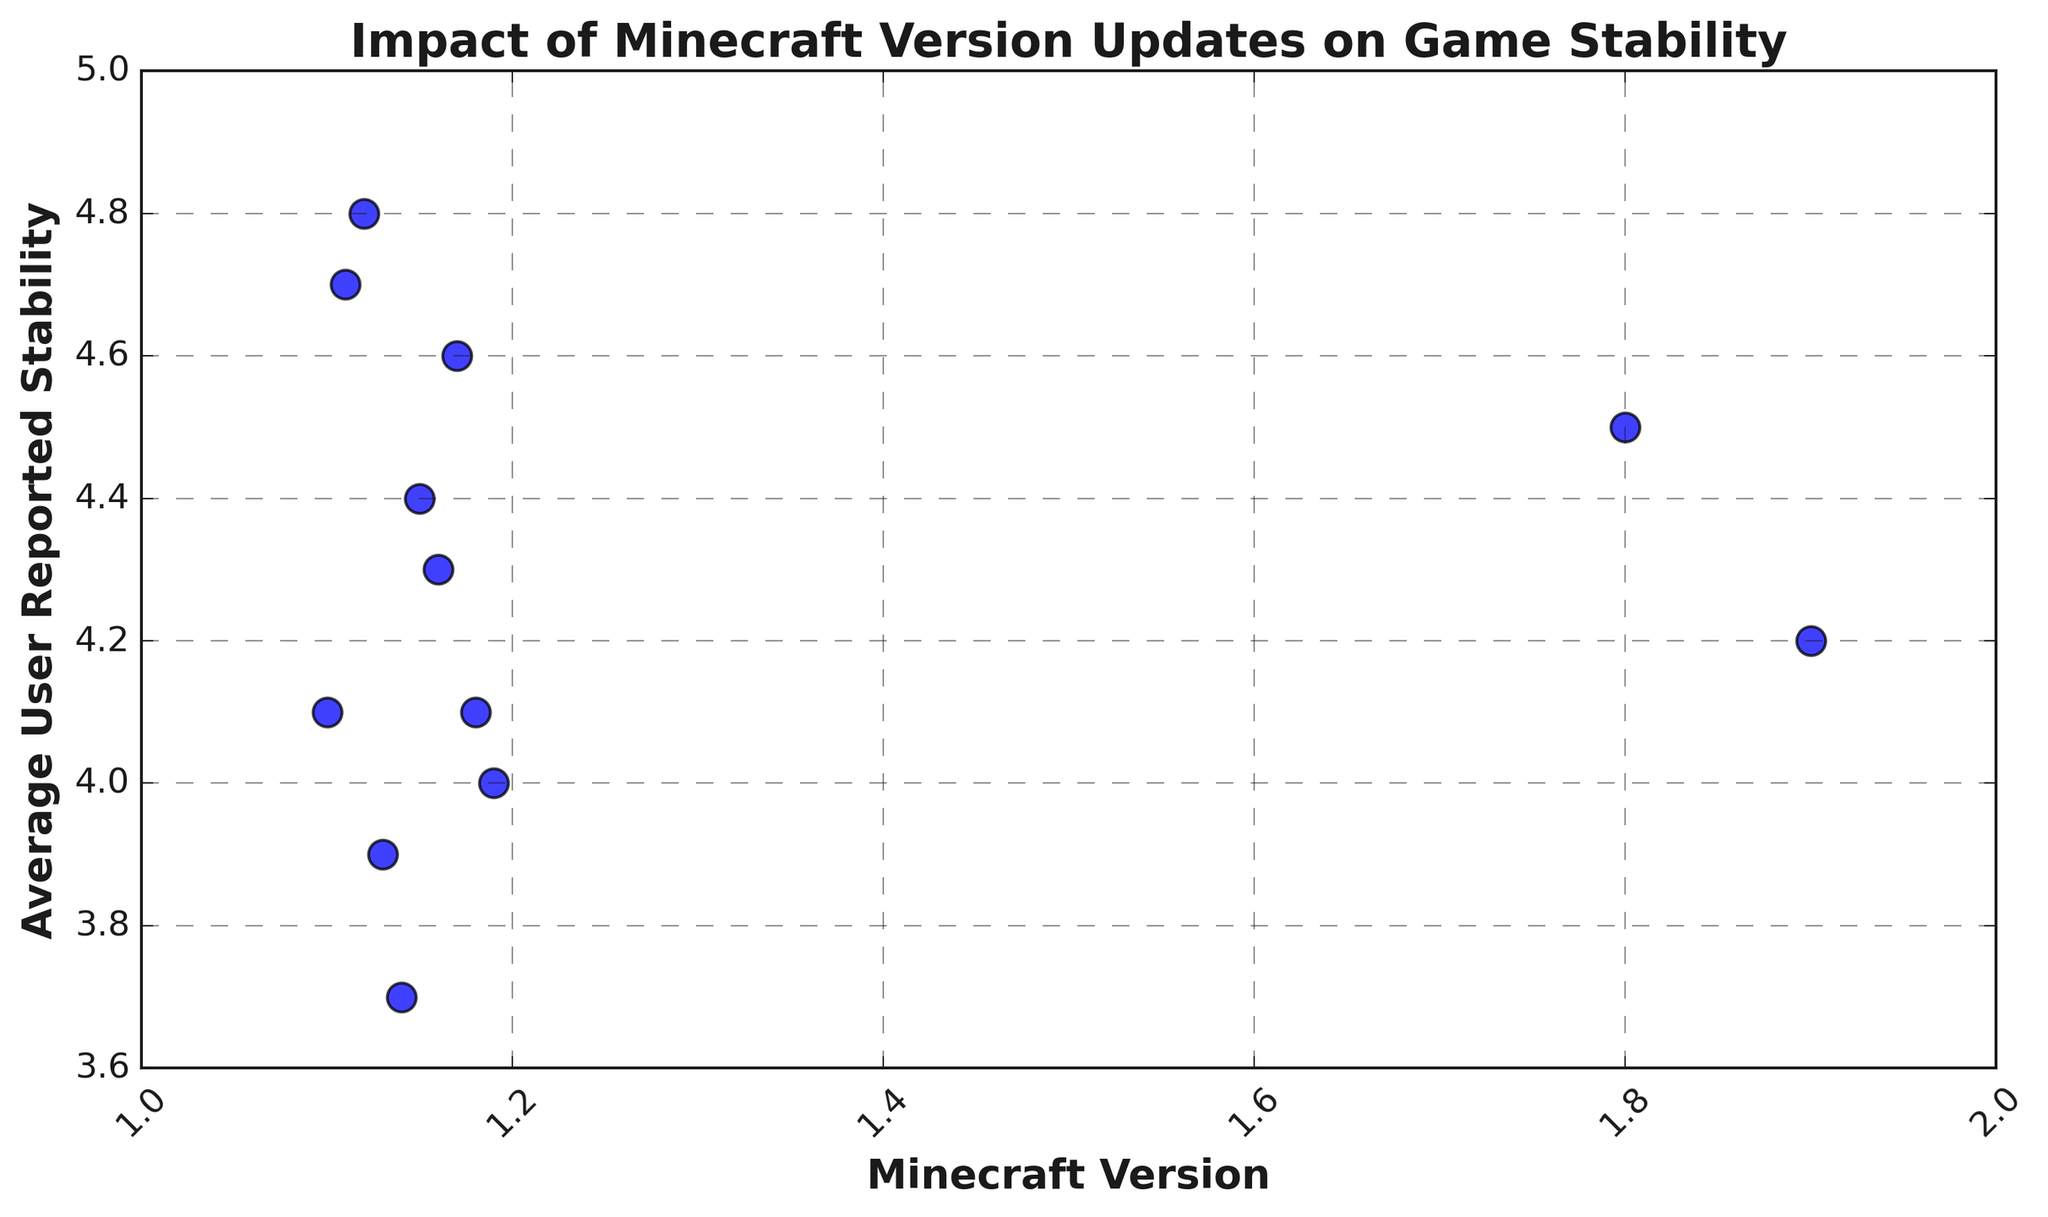Which Minecraft version has the highest average user-reported stability? The plot shows the average user-reported stability for different Minecraft versions. The highest point on the y-axis corresponds to version 1.12, with an average user-reported stability of 4.8.
Answer: 1.12 Which two versions have the lowest game stability ratings? The lowest game stability ratings on the y-axis correspond to versions 1.13 and 1.14, with average user-reported stabilities of 3.9 and 3.7, respectively.
Answer: 1.13 and 1.14 How does the stability of version 1.11 compare to version 1.16? Version 1.11 has a stability rating of 4.7, while version 1.16 has a stability rating of 4.3. Since 4.7 is greater than 4.3, version 1.11 has higher stability.
Answer: 1.11 is higher Which version shows a dip in stability right after a relatively high stability rating? Identify the version where a high stability rating is followed by a drop. Version 1.12 has a high stability of 4.8, and it dips to 3.9 in version 1.13.
Answer: 1.13 What is the average stability rating across all versions? Sum all stability ratings (4.5 + 4.2 + 4.1 + 4.7 + 4.8 + 3.9 + 3.7 + 4.4 + 4.3 + 4.6 + 4.1 + 4.0) and divide by the number of versions (12). The sum is 51.3, and the average is 51.3 / 12 = 4.275.
Answer: 4.275 Which version has a higher stability rating, 1.8 or 1.15? Compare the stability ratings for versions 1.8 (4.5) and 1.15 (4.4). Since 4.5 is greater than 4.4, version 1.8 has a higher stability rating.
Answer: 1.8 is higher What is the median stability rating among the displayed versions? Arrange the stability ratings in ascending order: 3.7, 3.9, 4.0, 4.1, 4.1, 4.2, 4.3, 4.4, 4.5, 4.6, 4.7, 4.8. The middle values are the 6th and 7th values (4.2 and 4.3). The median is the average of these values: (4.2 + 4.3) / 2 = 4.25.
Answer: 4.25 